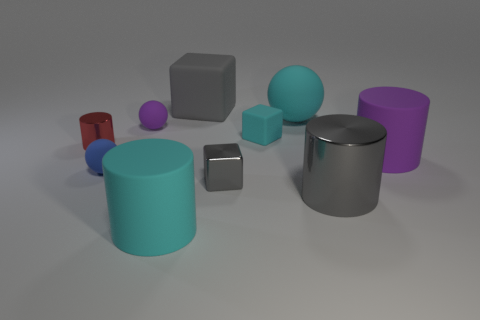Subtract all gray cubes. How many were subtracted if there are1gray cubes left? 1 Subtract all cylinders. How many objects are left? 6 Subtract all tiny purple matte objects. Subtract all small gray blocks. How many objects are left? 8 Add 4 large purple rubber cylinders. How many large purple rubber cylinders are left? 5 Add 6 small brown rubber objects. How many small brown rubber objects exist? 6 Subtract 1 cyan balls. How many objects are left? 9 